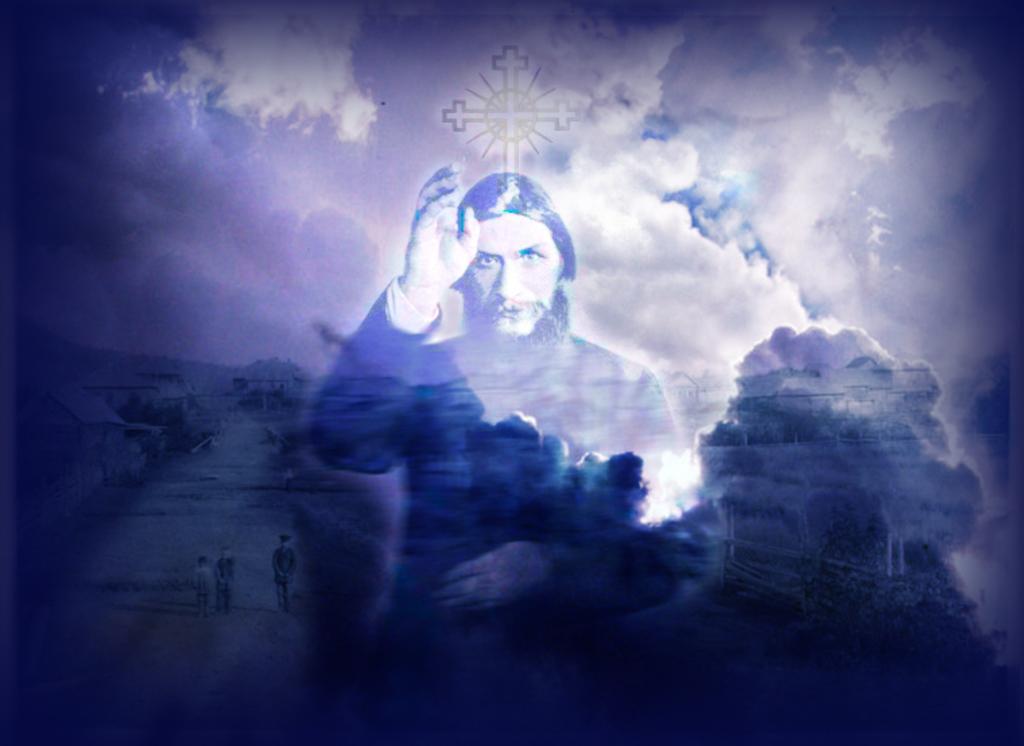Could you give a brief overview of what you see in this image? In this picture I can see a graphical image and I can see few people walking and I can see another human and a cross symbol and clouds in the sky. 